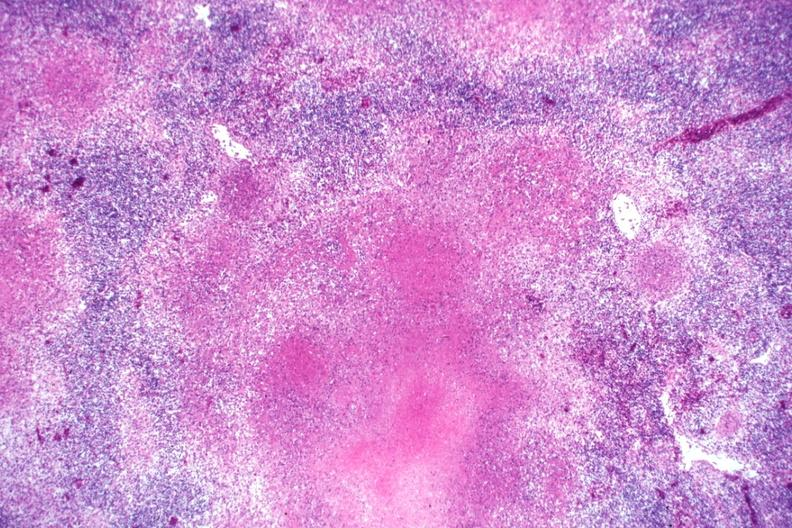s adenoma present?
Answer the question using a single word or phrase. No 